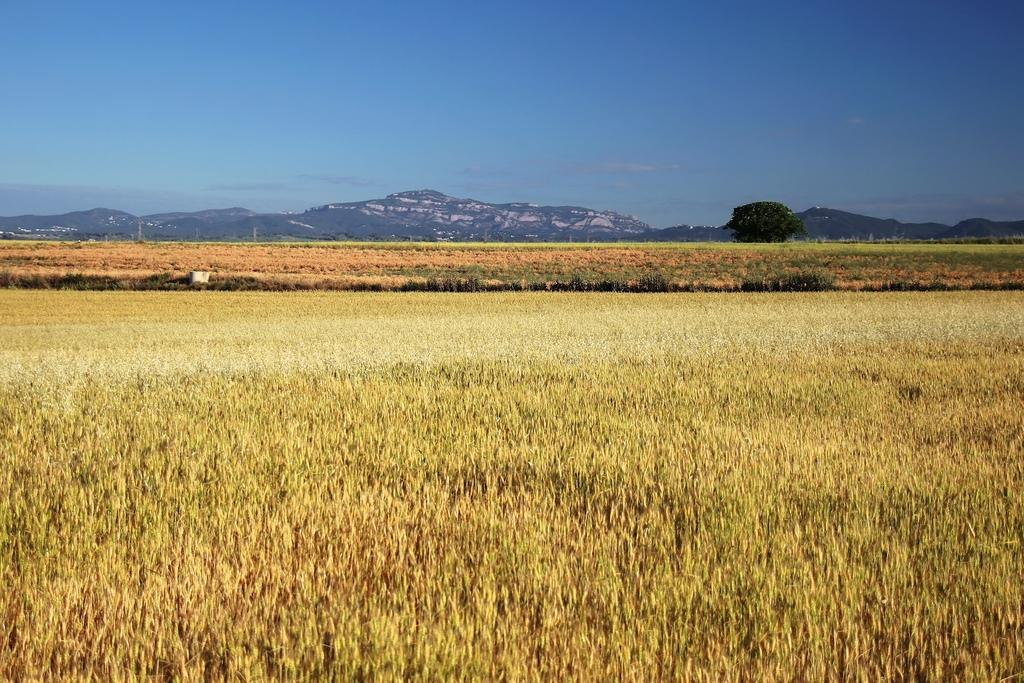What type of vegetation can be seen in the image? There is grass in the image. What geographical features are present in the image? There are hills in the image. What type of plant is visible in the image? There is a tree in the image. What color is the sky in the image? The sky is blue in the image. Where is the scarecrow located in the image? There is no scarecrow present in the image. What type of arch can be seen in the image? There is no arch present in the image. 